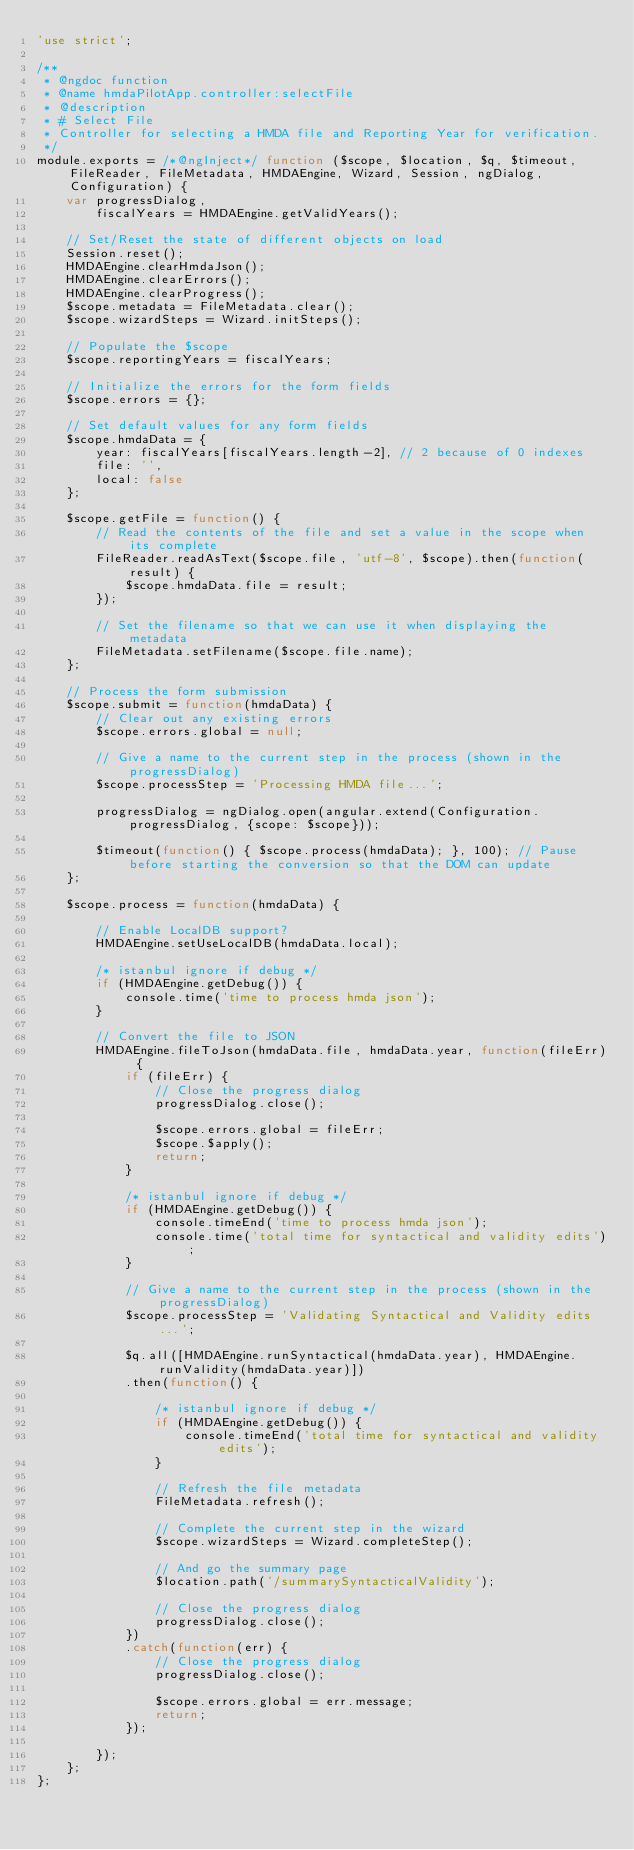Convert code to text. <code><loc_0><loc_0><loc_500><loc_500><_JavaScript_>'use strict';

/**
 * @ngdoc function
 * @name hmdaPilotApp.controller:selectFile
 * @description
 * # Select File
 * Controller for selecting a HMDA file and Reporting Year for verification.
 */
module.exports = /*@ngInject*/ function ($scope, $location, $q, $timeout, FileReader, FileMetadata, HMDAEngine, Wizard, Session, ngDialog, Configuration) {
    var progressDialog,
        fiscalYears = HMDAEngine.getValidYears();

    // Set/Reset the state of different objects on load
    Session.reset();
    HMDAEngine.clearHmdaJson();
    HMDAEngine.clearErrors();
    HMDAEngine.clearProgress();
    $scope.metadata = FileMetadata.clear();
    $scope.wizardSteps = Wizard.initSteps();

    // Populate the $scope
    $scope.reportingYears = fiscalYears;

    // Initialize the errors for the form fields
    $scope.errors = {};

    // Set default values for any form fields
    $scope.hmdaData = {
        year: fiscalYears[fiscalYears.length-2], // 2 because of 0 indexes
        file: '',
        local: false
    };

    $scope.getFile = function() {
        // Read the contents of the file and set a value in the scope when its complete
        FileReader.readAsText($scope.file, 'utf-8', $scope).then(function(result) {
            $scope.hmdaData.file = result;
        });

        // Set the filename so that we can use it when displaying the metadata
        FileMetadata.setFilename($scope.file.name);
    };

    // Process the form submission
    $scope.submit = function(hmdaData) {
        // Clear out any existing errors
        $scope.errors.global = null;

        // Give a name to the current step in the process (shown in the progressDialog)
        $scope.processStep = 'Processing HMDA file...';

        progressDialog = ngDialog.open(angular.extend(Configuration.progressDialog, {scope: $scope}));

        $timeout(function() { $scope.process(hmdaData); }, 100); // Pause before starting the conversion so that the DOM can update
    };

    $scope.process = function(hmdaData) {

        // Enable LocalDB support?
        HMDAEngine.setUseLocalDB(hmdaData.local);

        /* istanbul ignore if debug */
        if (HMDAEngine.getDebug()) {
            console.time('time to process hmda json');
        }

        // Convert the file to JSON
        HMDAEngine.fileToJson(hmdaData.file, hmdaData.year, function(fileErr) {
            if (fileErr) {
                // Close the progress dialog
                progressDialog.close();

                $scope.errors.global = fileErr;
                $scope.$apply();
                return;
            }

            /* istanbul ignore if debug */
            if (HMDAEngine.getDebug()) {
                console.timeEnd('time to process hmda json');
                console.time('total time for syntactical and validity edits');
            }

            // Give a name to the current step in the process (shown in the progressDialog)
            $scope.processStep = 'Validating Syntactical and Validity edits...';

            $q.all([HMDAEngine.runSyntactical(hmdaData.year), HMDAEngine.runValidity(hmdaData.year)])
            .then(function() {

                /* istanbul ignore if debug */
                if (HMDAEngine.getDebug()) {
                    console.timeEnd('total time for syntactical and validity edits');
                }

                // Refresh the file metadata
                FileMetadata.refresh();

                // Complete the current step in the wizard
                $scope.wizardSteps = Wizard.completeStep();

                // And go the summary page
                $location.path('/summarySyntacticalValidity');

                // Close the progress dialog
                progressDialog.close();
            })
            .catch(function(err) {
                // Close the progress dialog
                progressDialog.close();

                $scope.errors.global = err.message;
                return;
            });

        });
    };
};
</code> 